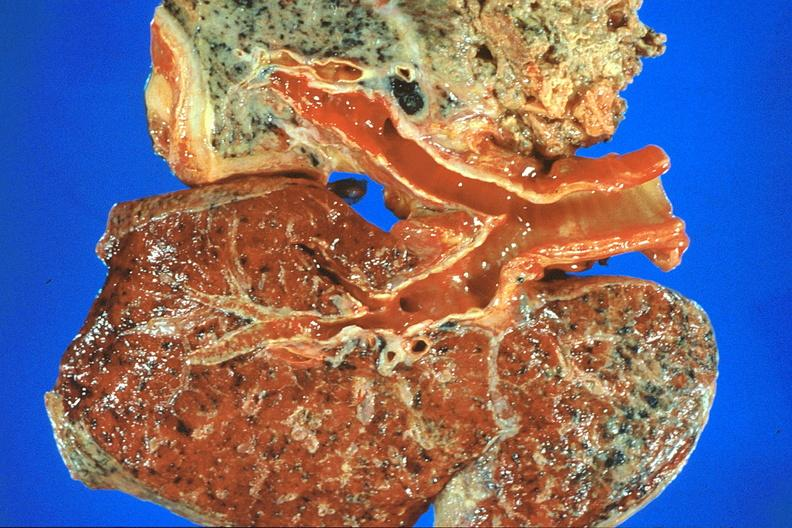what is present?
Answer the question using a single word or phrase. Respiratory 